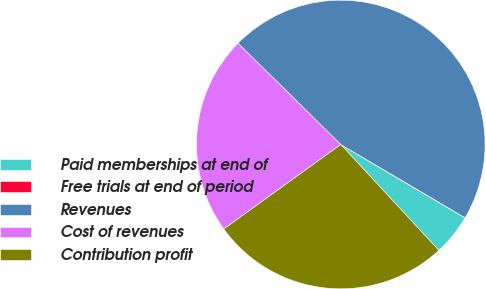<chart> <loc_0><loc_0><loc_500><loc_500><pie_chart><fcel>Paid memberships at end of<fcel>Free trials at end of period<fcel>Revenues<fcel>Cost of revenues<fcel>Contribution profit<nl><fcel>4.62%<fcel>0.01%<fcel>46.1%<fcel>22.34%<fcel>26.94%<nl></chart> 